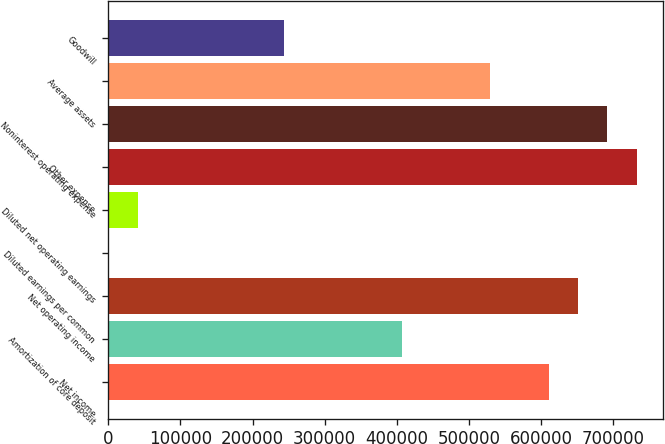<chart> <loc_0><loc_0><loc_500><loc_500><bar_chart><fcel>Net income<fcel>Amortization of core deposit<fcel>Net operating income<fcel>Diluted earnings per common<fcel>Diluted net operating earnings<fcel>Other expense<fcel>Noninterest operating expense<fcel>Average assets<fcel>Goodwill<nl><fcel>610382<fcel>406922<fcel>651074<fcel>1.56<fcel>40693.6<fcel>732458<fcel>691766<fcel>528998<fcel>244154<nl></chart> 